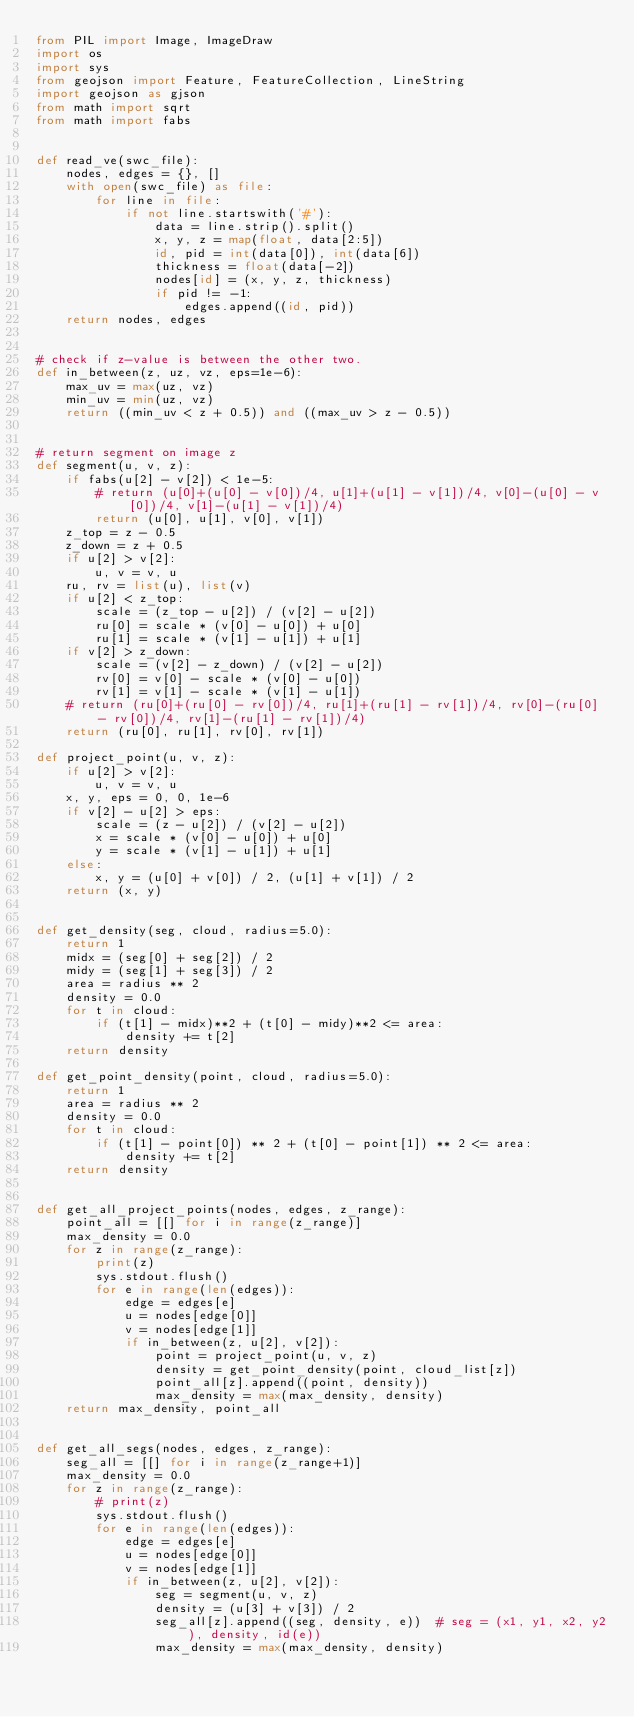<code> <loc_0><loc_0><loc_500><loc_500><_Python_>from PIL import Image, ImageDraw
import os
import sys
from geojson import Feature, FeatureCollection, LineString
import geojson as gjson
from math import sqrt
from math import fabs


def read_ve(swc_file):
    nodes, edges = {}, []
    with open(swc_file) as file:
        for line in file:
            if not line.startswith('#'):
                data = line.strip().split()
                x, y, z = map(float, data[2:5])
                id, pid = int(data[0]), int(data[6])
                thickness = float(data[-2])
                nodes[id] = (x, y, z, thickness)
                if pid != -1:
                    edges.append((id, pid))
    return nodes, edges


# check if z-value is between the other two.
def in_between(z, uz, vz, eps=1e-6):
    max_uv = max(uz, vz)
    min_uv = min(uz, vz)
    return ((min_uv < z + 0.5)) and ((max_uv > z - 0.5))


# return segment on image z
def segment(u, v, z):
    if fabs(u[2] - v[2]) < 1e-5:
        # return (u[0]+(u[0] - v[0])/4, u[1]+(u[1] - v[1])/4, v[0]-(u[0] - v[0])/4, v[1]-(u[1] - v[1])/4)
        return (u[0], u[1], v[0], v[1])
    z_top = z - 0.5
    z_down = z + 0.5
    if u[2] > v[2]:
        u, v = v, u
    ru, rv = list(u), list(v)
    if u[2] < z_top:
        scale = (z_top - u[2]) / (v[2] - u[2])
        ru[0] = scale * (v[0] - u[0]) + u[0]
        ru[1] = scale * (v[1] - u[1]) + u[1]
    if v[2] > z_down:
        scale = (v[2] - z_down) / (v[2] - u[2])
        rv[0] = v[0] - scale * (v[0] - u[0])
        rv[1] = v[1] - scale * (v[1] - u[1])
    # return (ru[0]+(ru[0] - rv[0])/4, ru[1]+(ru[1] - rv[1])/4, rv[0]-(ru[0] - rv[0])/4, rv[1]-(ru[1] - rv[1])/4)
    return (ru[0], ru[1], rv[0], rv[1])

def project_point(u, v, z):
    if u[2] > v[2]:
        u, v = v, u
    x, y, eps = 0, 0, 1e-6
    if v[2] - u[2] > eps:
        scale = (z - u[2]) / (v[2] - u[2])
        x = scale * (v[0] - u[0]) + u[0]
        y = scale * (v[1] - u[1]) + u[1]
    else:
        x, y = (u[0] + v[0]) / 2, (u[1] + v[1]) / 2
    return (x, y)


def get_density(seg, cloud, radius=5.0):
    return 1
    midx = (seg[0] + seg[2]) / 2
    midy = (seg[1] + seg[3]) / 2
    area = radius ** 2
    density = 0.0
    for t in cloud:
        if (t[1] - midx)**2 + (t[0] - midy)**2 <= area:
            density += t[2]
    return density

def get_point_density(point, cloud, radius=5.0):
    return 1
    area = radius ** 2
    density = 0.0
    for t in cloud:
        if (t[1] - point[0]) ** 2 + (t[0] - point[1]) ** 2 <= area:
            density += t[2]
    return density


def get_all_project_points(nodes, edges, z_range):
    point_all = [[] for i in range(z_range)]
    max_density = 0.0
    for z in range(z_range):
        print(z)
        sys.stdout.flush()
        for e in range(len(edges)):
            edge = edges[e]
            u = nodes[edge[0]]
            v = nodes[edge[1]]
            if in_between(z, u[2], v[2]):
                point = project_point(u, v, z)
                density = get_point_density(point, cloud_list[z])
                point_all[z].append((point, density))
                max_density = max(max_density, density)
    return max_density, point_all


def get_all_segs(nodes, edges, z_range):
    seg_all = [[] for i in range(z_range+1)]
    max_density = 0.0
    for z in range(z_range):
        # print(z)
        sys.stdout.flush()
        for e in range(len(edges)):
            edge = edges[e]
            u = nodes[edge[0]]
            v = nodes[edge[1]]
            if in_between(z, u[2], v[2]):
                seg = segment(u, v, z)
                density = (u[3] + v[3]) / 2
                seg_all[z].append((seg, density, e))  # seg = (x1, y1, x2, y2), density, id(e))
                max_density = max(max_density, density)</code> 